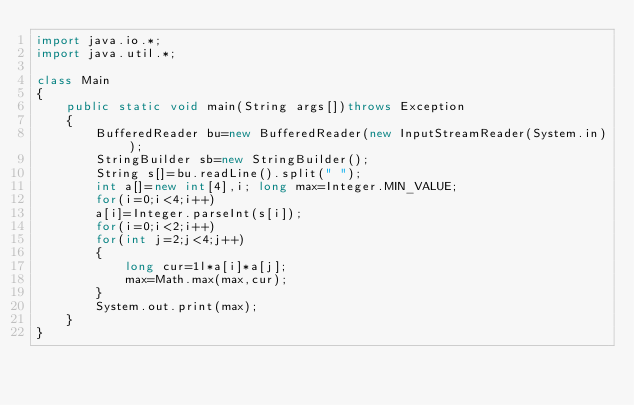<code> <loc_0><loc_0><loc_500><loc_500><_Java_>import java.io.*;
import java.util.*;

class Main
{
    public static void main(String args[])throws Exception
    {
        BufferedReader bu=new BufferedReader(new InputStreamReader(System.in));
        StringBuilder sb=new StringBuilder();
        String s[]=bu.readLine().split(" ");
        int a[]=new int[4],i; long max=Integer.MIN_VALUE;
        for(i=0;i<4;i++)
        a[i]=Integer.parseInt(s[i]);
        for(i=0;i<2;i++)
        for(int j=2;j<4;j++)
        {
            long cur=1l*a[i]*a[j];
            max=Math.max(max,cur);
        }
        System.out.print(max);
    }
}
</code> 